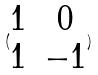<formula> <loc_0><loc_0><loc_500><loc_500>( \begin{matrix} 1 & 0 \\ 1 & - 1 \end{matrix} )</formula> 